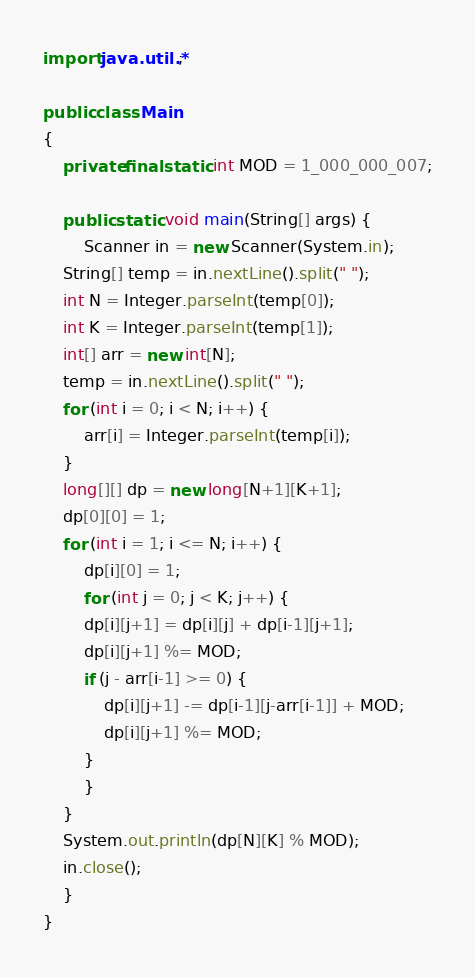<code> <loc_0><loc_0><loc_500><loc_500><_Java_>import java.util.*;
 
public class Main
{
    private final static int MOD = 1_000_000_007;
 
    public static void main(String[] args) {
        Scanner in = new Scanner(System.in);
	String[] temp = in.nextLine().split(" ");
	int N = Integer.parseInt(temp[0]);
	int K = Integer.parseInt(temp[1]);
	int[] arr = new int[N];
	temp = in.nextLine().split(" ");
	for (int i = 0; i < N; i++) {
	    arr[i] = Integer.parseInt(temp[i]);
	}
	long[][] dp = new long[N+1][K+1];
	dp[0][0] = 1;
	for (int i = 1; i <= N; i++) {
	    dp[i][0] = 1;
	    for (int j = 0; j < K; j++) {
		dp[i][j+1] = dp[i][j] + dp[i-1][j+1];
		dp[i][j+1] %= MOD;
		if (j - arr[i-1] >= 0) {
		    dp[i][j+1] -= dp[i-1][j-arr[i-1]] + MOD;
		    dp[i][j+1] %= MOD;
		}
	    }
	}
	System.out.println(dp[N][K] % MOD);
	in.close();
    }
}
</code> 